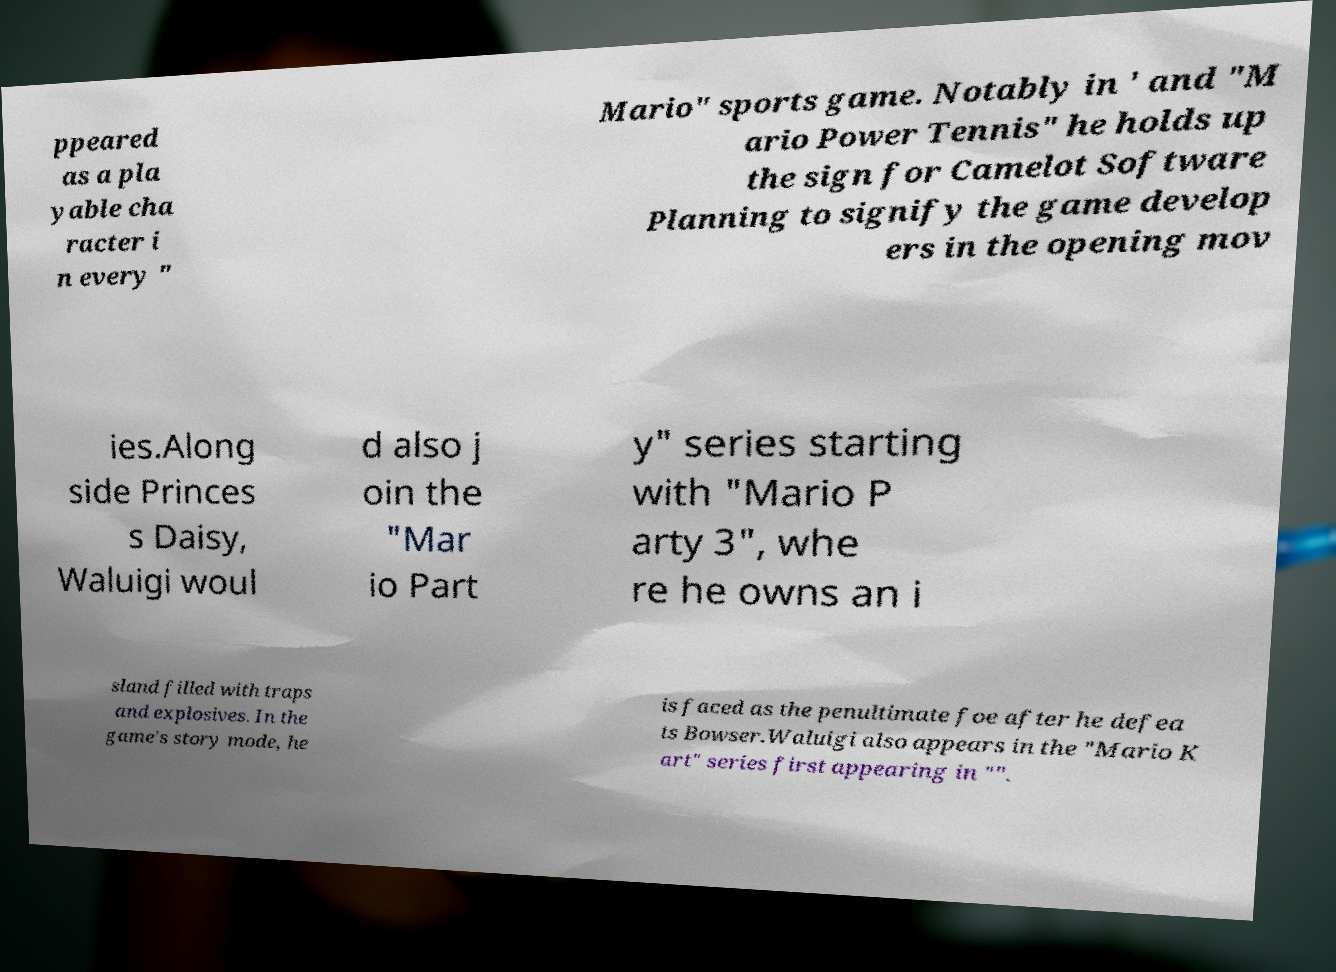For documentation purposes, I need the text within this image transcribed. Could you provide that? ppeared as a pla yable cha racter i n every " Mario" sports game. Notably in ' and "M ario Power Tennis" he holds up the sign for Camelot Software Planning to signify the game develop ers in the opening mov ies.Along side Princes s Daisy, Waluigi woul d also j oin the "Mar io Part y" series starting with "Mario P arty 3", whe re he owns an i sland filled with traps and explosives. In the game's story mode, he is faced as the penultimate foe after he defea ts Bowser.Waluigi also appears in the "Mario K art" series first appearing in "". 